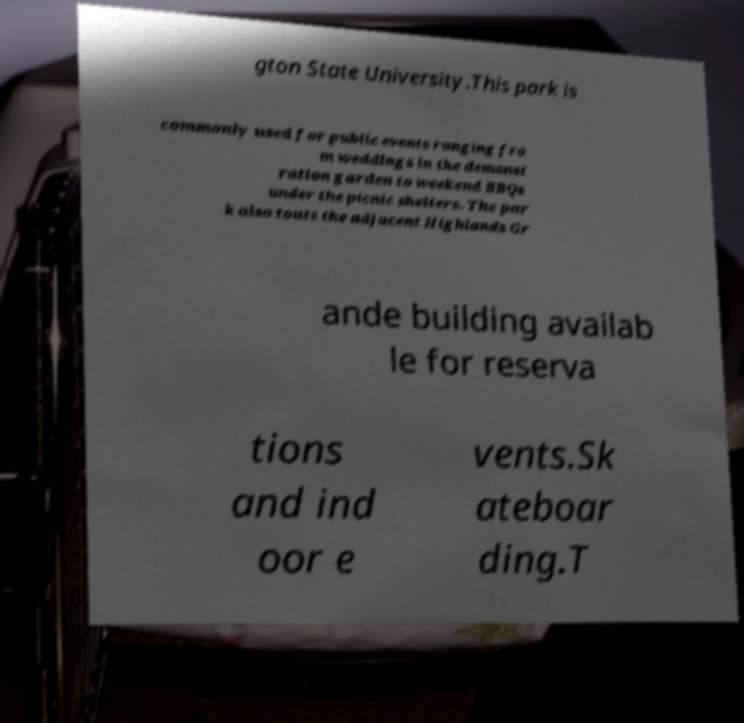Could you assist in decoding the text presented in this image and type it out clearly? gton State University.This park is commonly used for public events ranging fro m weddings in the demonst ration garden to weekend BBQs under the picnic shelters. The par k also touts the adjacent Highlands Gr ande building availab le for reserva tions and ind oor e vents.Sk ateboar ding.T 